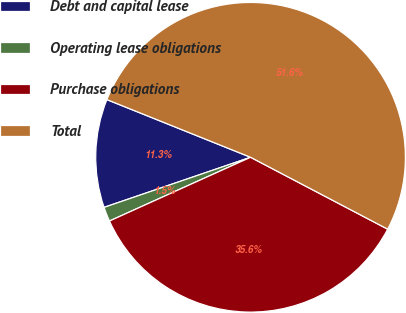Convert chart. <chart><loc_0><loc_0><loc_500><loc_500><pie_chart><fcel>Debt and capital lease<fcel>Operating lease obligations<fcel>Purchase obligations<fcel>Total<nl><fcel>11.32%<fcel>1.51%<fcel>35.56%<fcel>51.61%<nl></chart> 